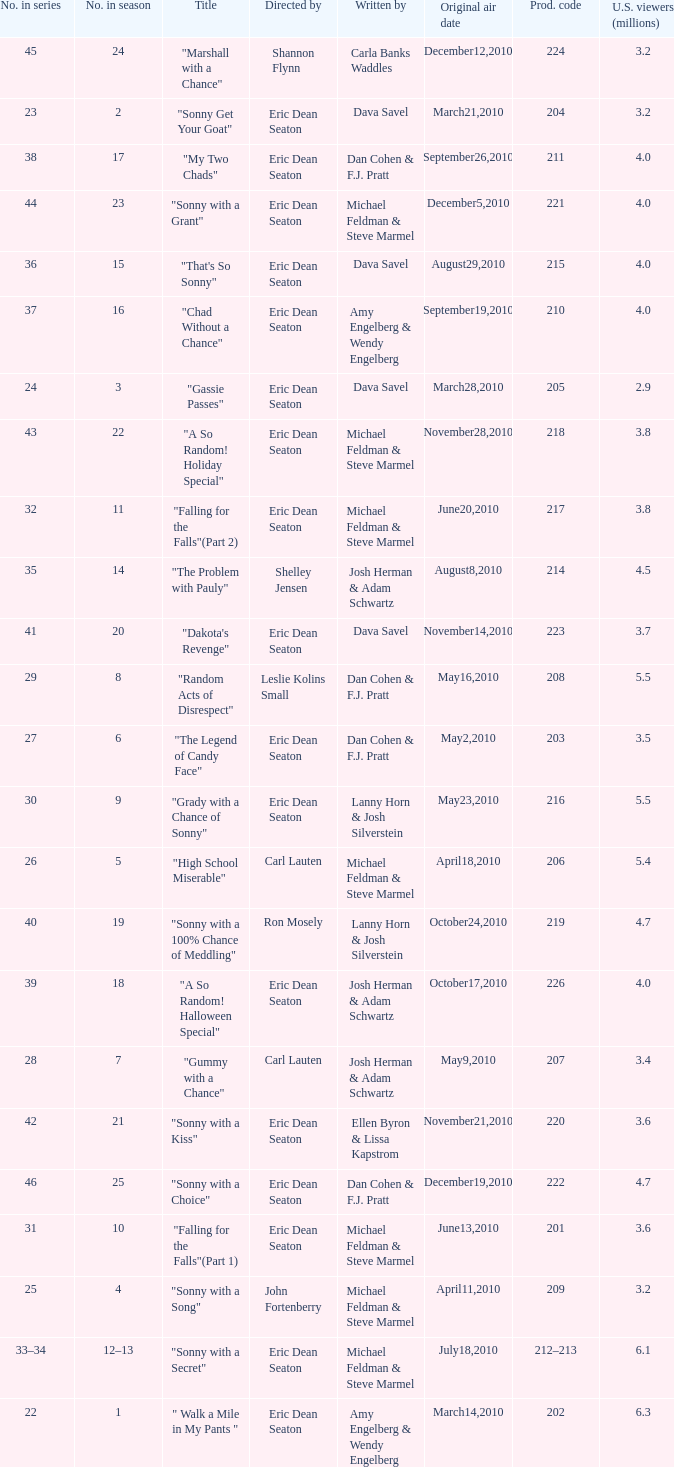Who directed the episode that 6.3 million u.s. viewers saw? Eric Dean Seaton. 